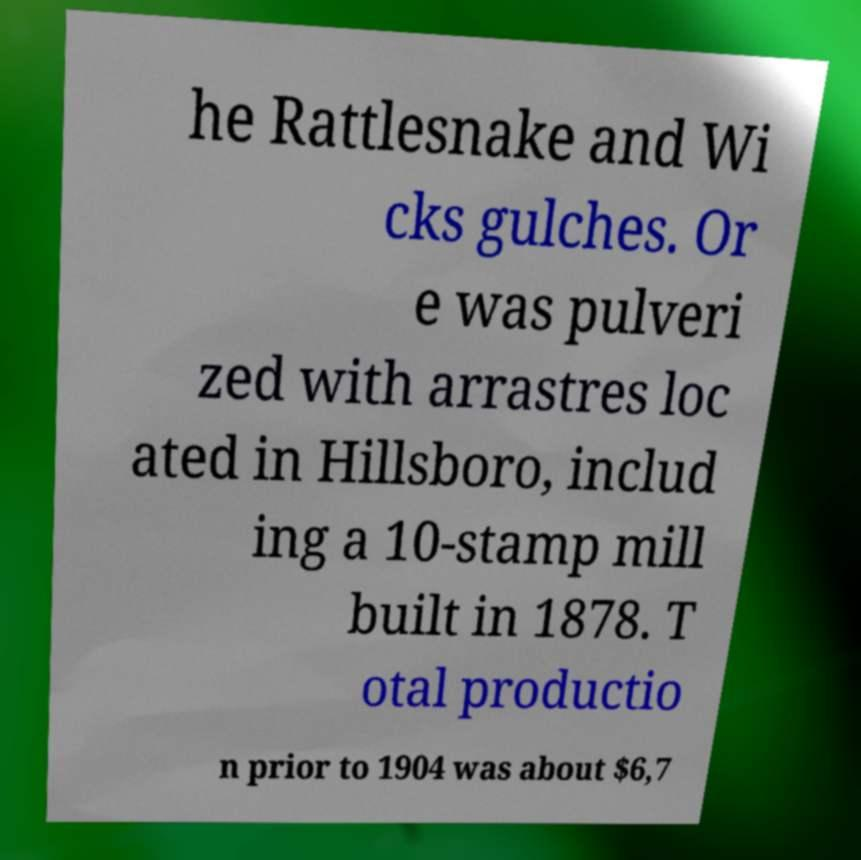Could you assist in decoding the text presented in this image and type it out clearly? he Rattlesnake and Wi cks gulches. Or e was pulveri zed with arrastres loc ated in Hillsboro, includ ing a 10-stamp mill built in 1878. T otal productio n prior to 1904 was about $6,7 